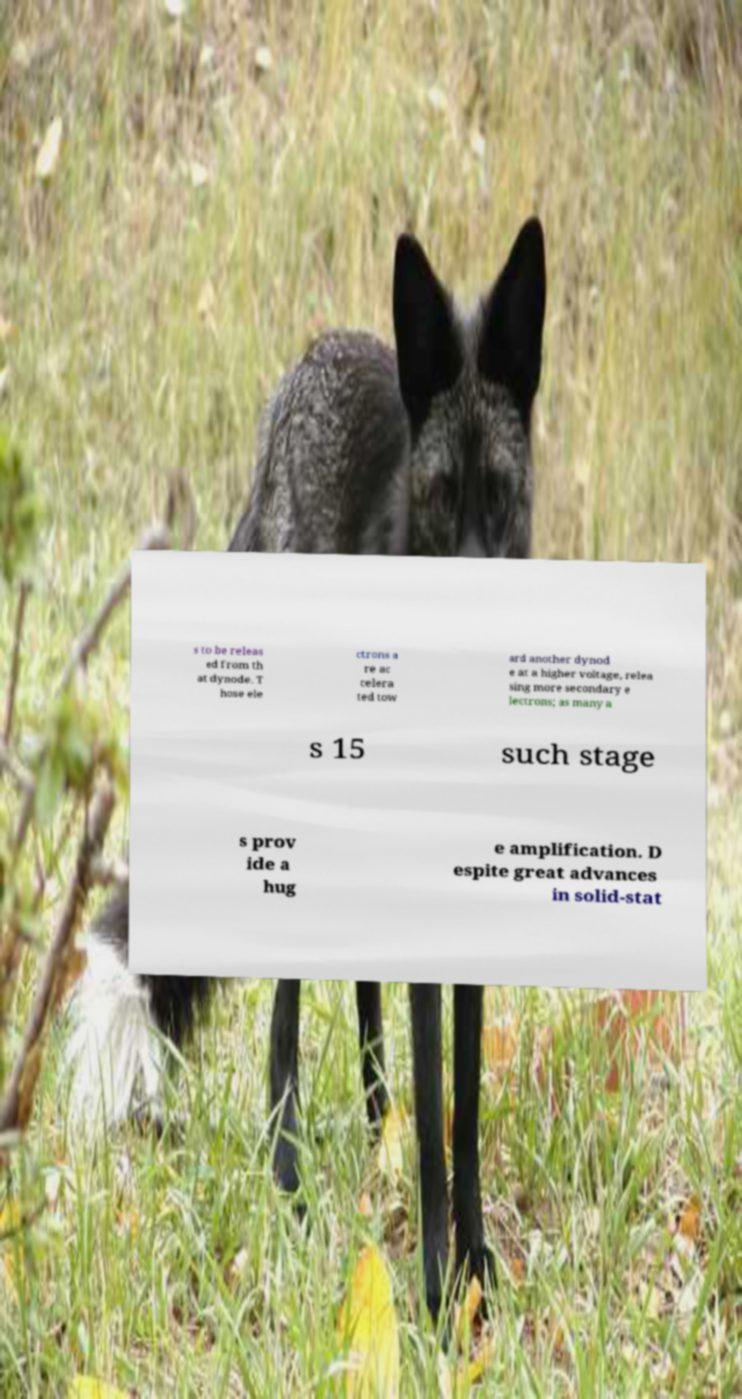Please identify and transcribe the text found in this image. s to be releas ed from th at dynode. T hose ele ctrons a re ac celera ted tow ard another dynod e at a higher voltage, relea sing more secondary e lectrons; as many a s 15 such stage s prov ide a hug e amplification. D espite great advances in solid-stat 